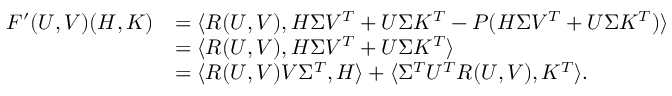<formula> <loc_0><loc_0><loc_500><loc_500>\begin{array} { r l } { F ^ { \prime } ( U , V ) ( H , K ) } & { = \langle R ( U , V ) , H \Sigma V ^ { T } + U \Sigma K ^ { T } - P ( H \Sigma V ^ { T } + U \Sigma K ^ { T } ) \rangle } \\ & { = \langle R ( U , V ) , H \Sigma V ^ { T } + U \Sigma K ^ { T } \rangle } \\ & { = \langle R ( U , V ) V \Sigma ^ { T } , H \rangle + \langle \Sigma ^ { T } U ^ { T } R ( U , V ) , K ^ { T } \rangle . } \end{array}</formula> 